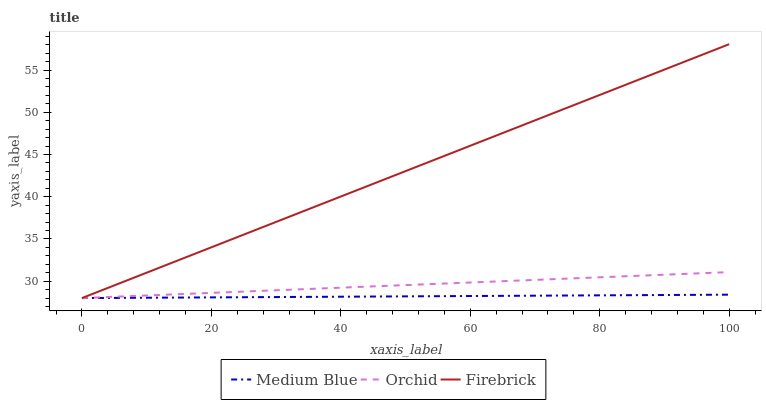Does Medium Blue have the minimum area under the curve?
Answer yes or no. Yes. Does Firebrick have the maximum area under the curve?
Answer yes or no. Yes. Does Orchid have the minimum area under the curve?
Answer yes or no. No. Does Orchid have the maximum area under the curve?
Answer yes or no. No. Is Firebrick the smoothest?
Answer yes or no. Yes. Is Medium Blue the roughest?
Answer yes or no. Yes. Is Orchid the smoothest?
Answer yes or no. No. Is Orchid the roughest?
Answer yes or no. No. Does Firebrick have the lowest value?
Answer yes or no. Yes. Does Firebrick have the highest value?
Answer yes or no. Yes. Does Orchid have the highest value?
Answer yes or no. No. Does Firebrick intersect Orchid?
Answer yes or no. Yes. Is Firebrick less than Orchid?
Answer yes or no. No. Is Firebrick greater than Orchid?
Answer yes or no. No. 